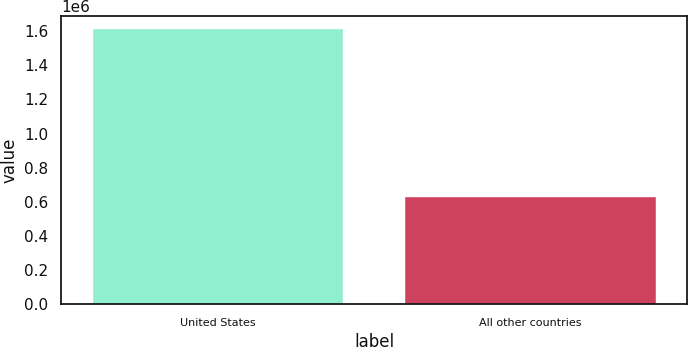Convert chart to OTSL. <chart><loc_0><loc_0><loc_500><loc_500><bar_chart><fcel>United States<fcel>All other countries<nl><fcel>1.61002e+06<fcel>627568<nl></chart> 